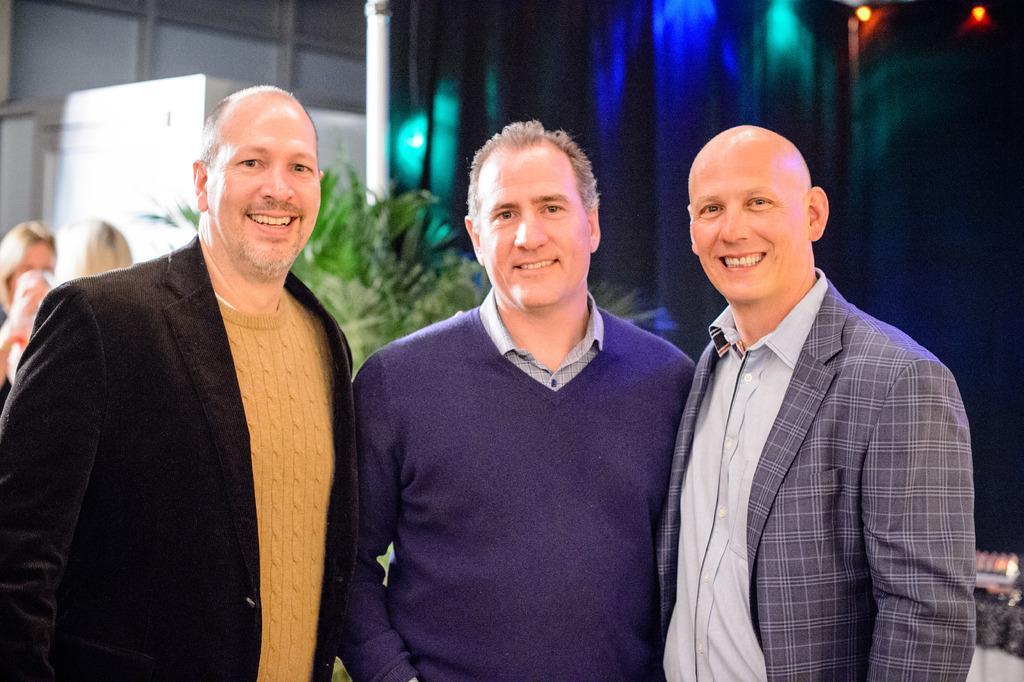In one or two sentences, can you explain what this image depicts? In this picture, we can see a few people and in the background, we can see curtain with some lights, poles, plants and some objects in the top left corner. 